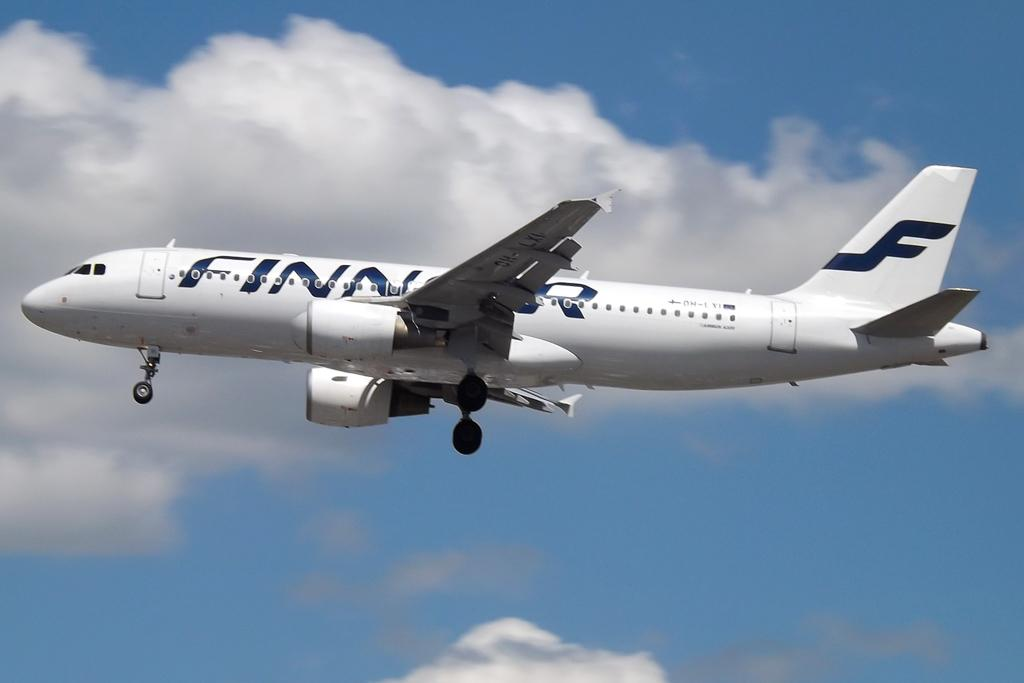<image>
Provide a brief description of the given image. A large white airplane is flying in the sky and on the side it says FINNAIR in black. 